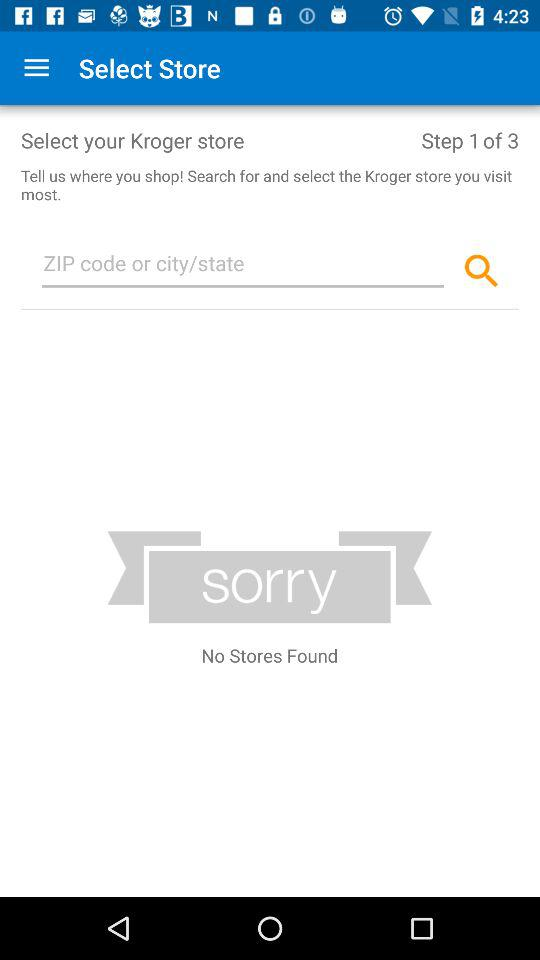How many steps in total are shown here? There are total 3 steps. 